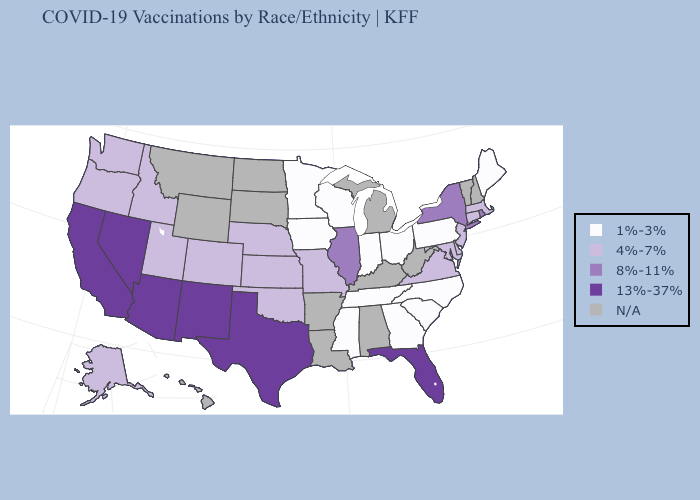What is the value of California?
Answer briefly. 13%-37%. Name the states that have a value in the range 8%-11%?
Short answer required. Illinois, New York, Rhode Island. Name the states that have a value in the range 13%-37%?
Concise answer only. Arizona, California, Florida, Nevada, New Mexico, Texas. Which states have the lowest value in the MidWest?
Concise answer only. Indiana, Iowa, Minnesota, Ohio, Wisconsin. What is the value of Utah?
Write a very short answer. 4%-7%. What is the value of Vermont?
Answer briefly. N/A. What is the lowest value in the Northeast?
Answer briefly. 1%-3%. What is the value of Wisconsin?
Write a very short answer. 1%-3%. Does Virginia have the highest value in the USA?
Give a very brief answer. No. What is the lowest value in the USA?
Give a very brief answer. 1%-3%. Does the first symbol in the legend represent the smallest category?
Quick response, please. Yes. Name the states that have a value in the range 4%-7%?
Answer briefly. Alaska, Colorado, Connecticut, Delaware, Idaho, Kansas, Maryland, Massachusetts, Missouri, Nebraska, New Jersey, Oklahoma, Oregon, Utah, Virginia, Washington. What is the highest value in states that border Massachusetts?
Keep it brief. 8%-11%. 